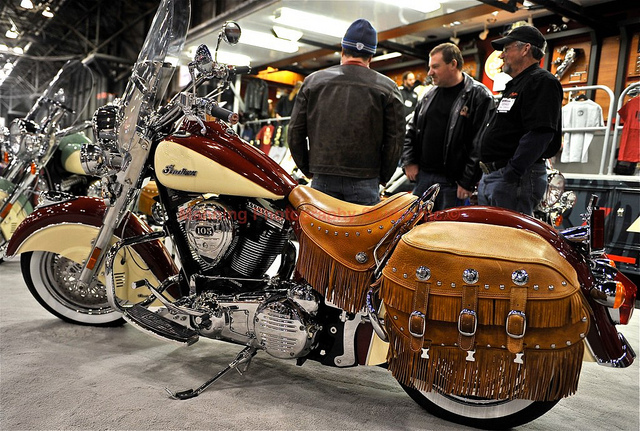Read all the text in this image. 103 